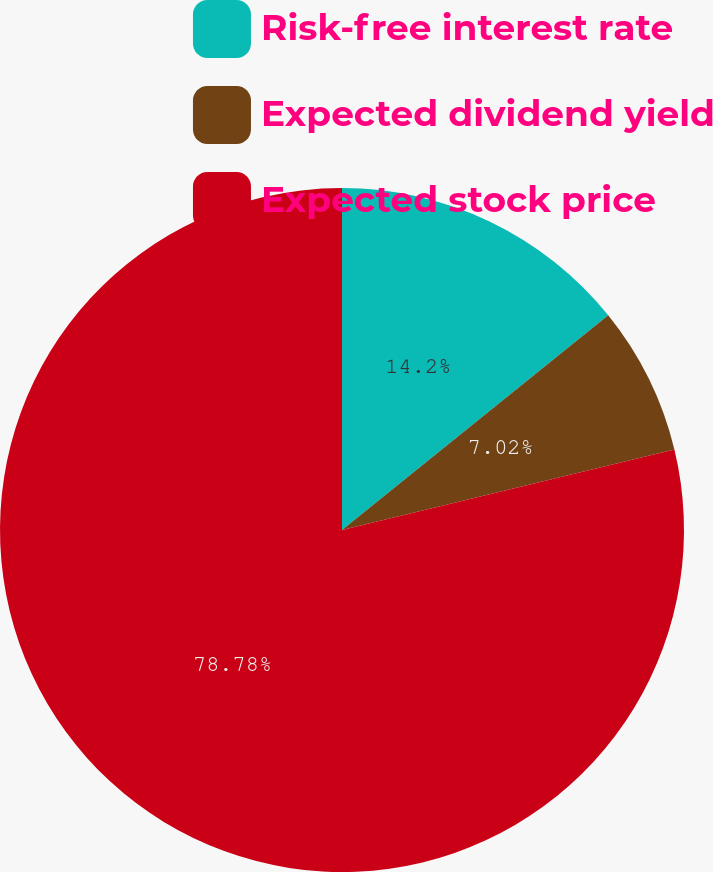Convert chart to OTSL. <chart><loc_0><loc_0><loc_500><loc_500><pie_chart><fcel>Risk-free interest rate<fcel>Expected dividend yield<fcel>Expected stock price<nl><fcel>14.2%<fcel>7.02%<fcel>78.78%<nl></chart> 